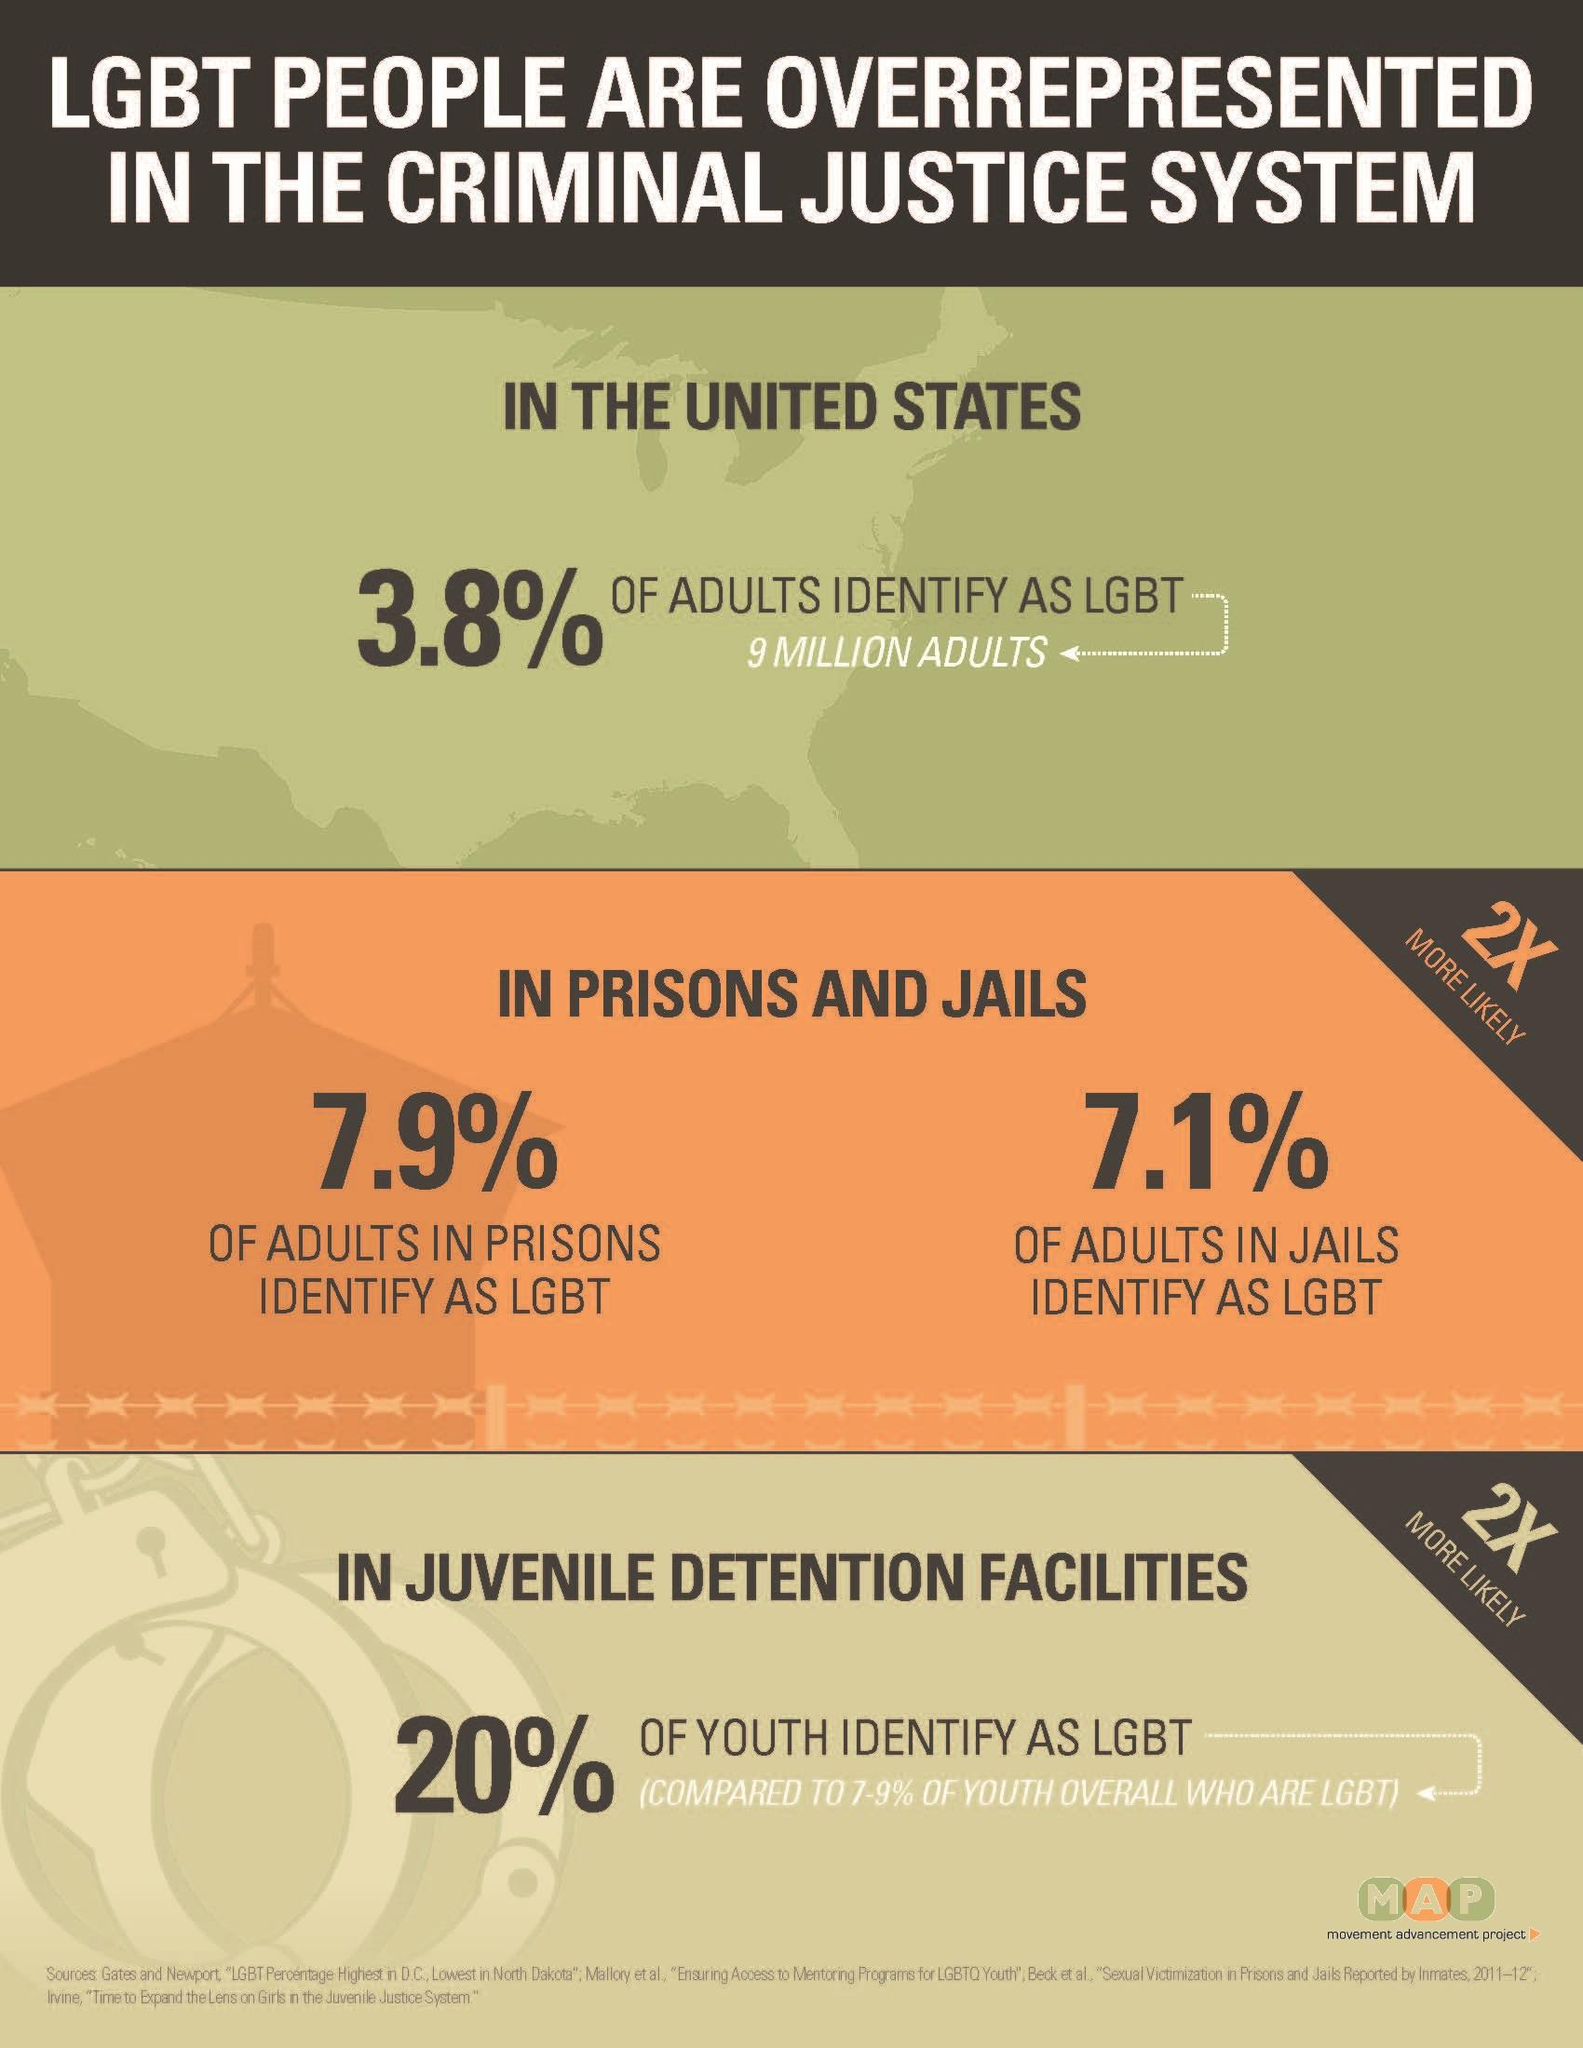Identify some key points in this picture. According to a recent study, a significant percentage of adults in prisons identify as LGBT, with 7.9% of the population falling into this category. A recent study found that 20% of LGBT individuals are currently detained in juvenile detention centers. This is higher than the previous estimates of 7.9% and 7.1%. Approximately 15% of adults in jails and prisons identify as LGBT, according to recent surveys. 